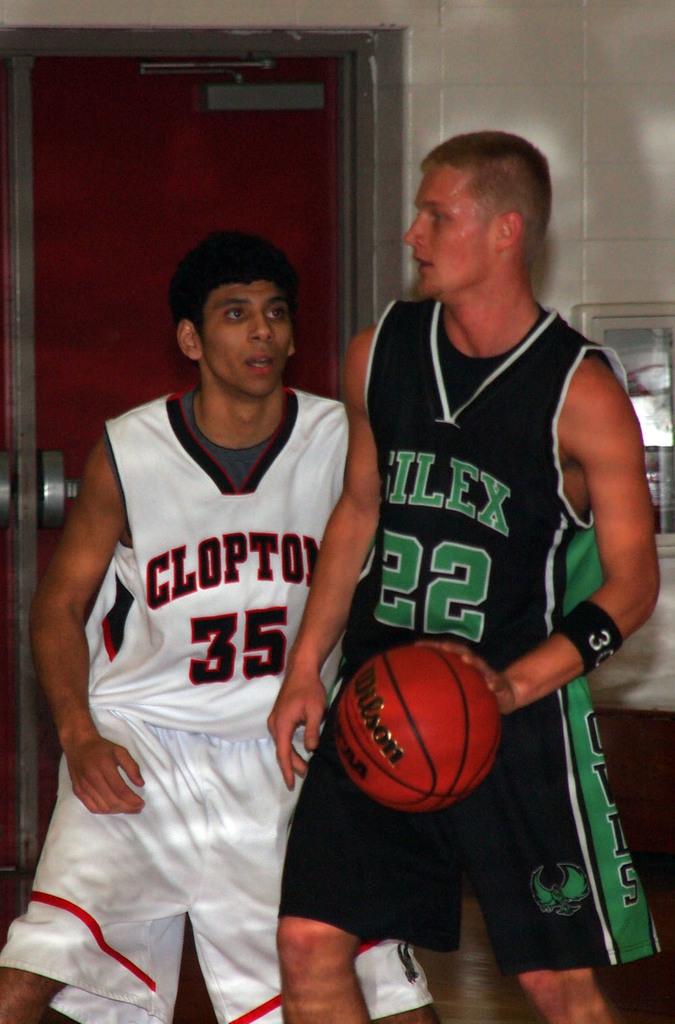What name does the shirt say that the boy with the white shirt has on?
Offer a very short reply. Clopton. What is the number of the black and green jersey?
Provide a succinct answer. 22. 